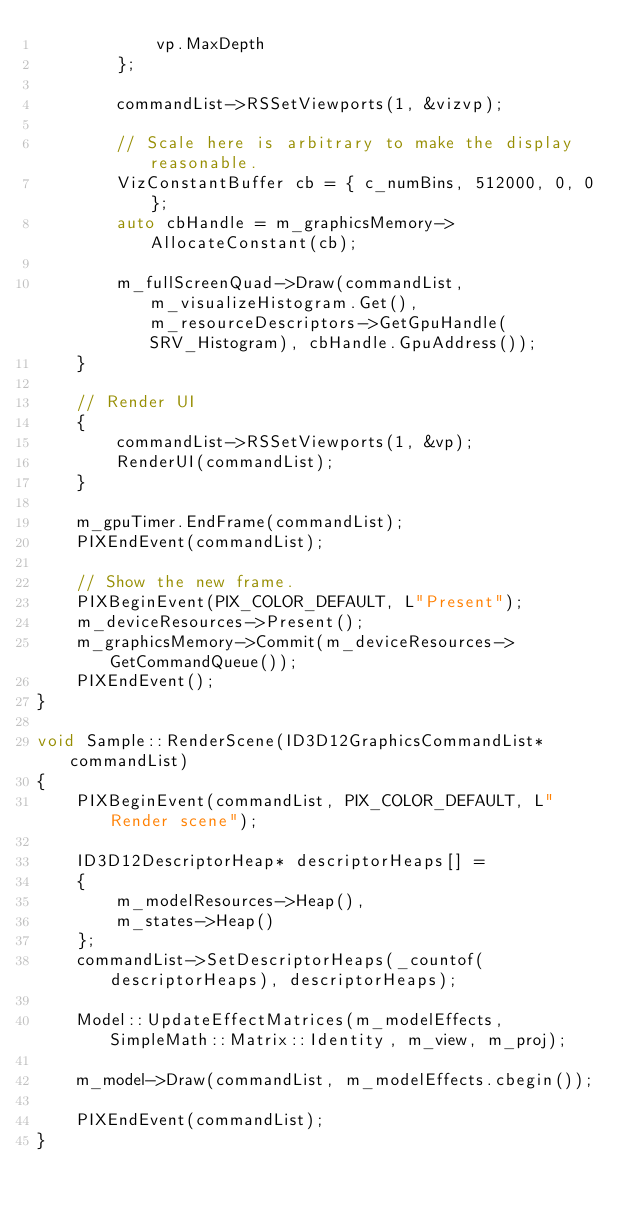<code> <loc_0><loc_0><loc_500><loc_500><_C++_>            vp.MaxDepth
        };

        commandList->RSSetViewports(1, &vizvp);

        // Scale here is arbitrary to make the display reasonable.
        VizConstantBuffer cb = { c_numBins, 512000, 0, 0 };
        auto cbHandle = m_graphicsMemory->AllocateConstant(cb);

        m_fullScreenQuad->Draw(commandList, m_visualizeHistogram.Get(), m_resourceDescriptors->GetGpuHandle(SRV_Histogram), cbHandle.GpuAddress());
    }

    // Render UI
    {
        commandList->RSSetViewports(1, &vp);
        RenderUI(commandList);
    }

    m_gpuTimer.EndFrame(commandList);
    PIXEndEvent(commandList);

    // Show the new frame.
    PIXBeginEvent(PIX_COLOR_DEFAULT, L"Present");
    m_deviceResources->Present();
    m_graphicsMemory->Commit(m_deviceResources->GetCommandQueue());
    PIXEndEvent();
}

void Sample::RenderScene(ID3D12GraphicsCommandList* commandList)
{
    PIXBeginEvent(commandList, PIX_COLOR_DEFAULT, L"Render scene");

    ID3D12DescriptorHeap* descriptorHeaps[] =
    {
        m_modelResources->Heap(),
        m_states->Heap()
    };
    commandList->SetDescriptorHeaps(_countof(descriptorHeaps), descriptorHeaps);

    Model::UpdateEffectMatrices(m_modelEffects, SimpleMath::Matrix::Identity, m_view, m_proj);

    m_model->Draw(commandList, m_modelEffects.cbegin());

    PIXEndEvent(commandList);
}
</code> 